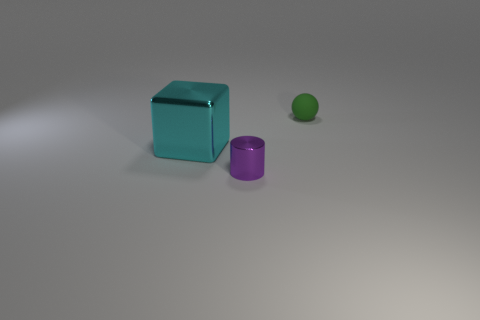There is a small metal cylinder; does it have the same color as the small ball that is right of the cylinder?
Give a very brief answer. No. Are there any red spheres that have the same material as the cube?
Provide a succinct answer. No. What number of tiny cyan blocks are there?
Your response must be concise. 0. The small thing to the right of the tiny thing in front of the metal cube is made of what material?
Ensure brevity in your answer.  Rubber. The large block that is made of the same material as the tiny purple thing is what color?
Your answer should be very brief. Cyan. Does the thing that is behind the large cyan metallic thing have the same size as the object that is in front of the shiny cube?
Provide a succinct answer. Yes. What number of cubes are cyan shiny things or big red rubber things?
Offer a very short reply. 1. Is the small object in front of the green matte sphere made of the same material as the cyan object?
Ensure brevity in your answer.  Yes. How many other objects are the same size as the purple metallic cylinder?
Ensure brevity in your answer.  1. How many large things are either purple shiny cylinders or green rubber balls?
Your response must be concise. 0. 